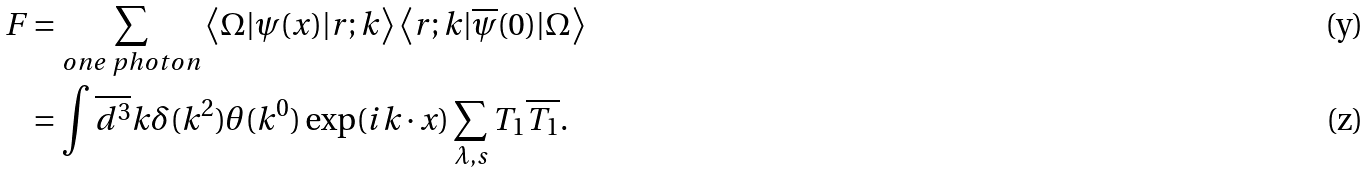Convert formula to latex. <formula><loc_0><loc_0><loc_500><loc_500>F & = \sum _ { o n e \text { } p h o t o n } \left \langle \Omega | \psi ( x ) | r ; k \right \rangle \left \langle r ; k | \overline { \psi } ( 0 ) | \Omega \right \rangle \\ & = \int \overline { d ^ { 3 } } k \delta ( k ^ { 2 } ) \theta ( k ^ { 0 } ) \exp ( i k \cdot x ) \sum _ { \lambda , s } T _ { 1 } \overline { T _ { 1 } } .</formula> 